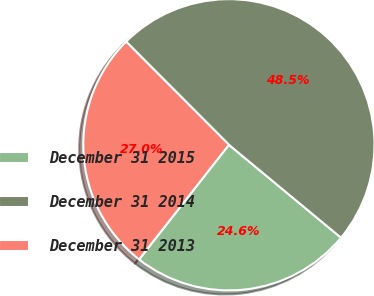Convert chart to OTSL. <chart><loc_0><loc_0><loc_500><loc_500><pie_chart><fcel>December 31 2015<fcel>December 31 2014<fcel>December 31 2013<nl><fcel>24.56%<fcel>48.49%<fcel>26.95%<nl></chart> 